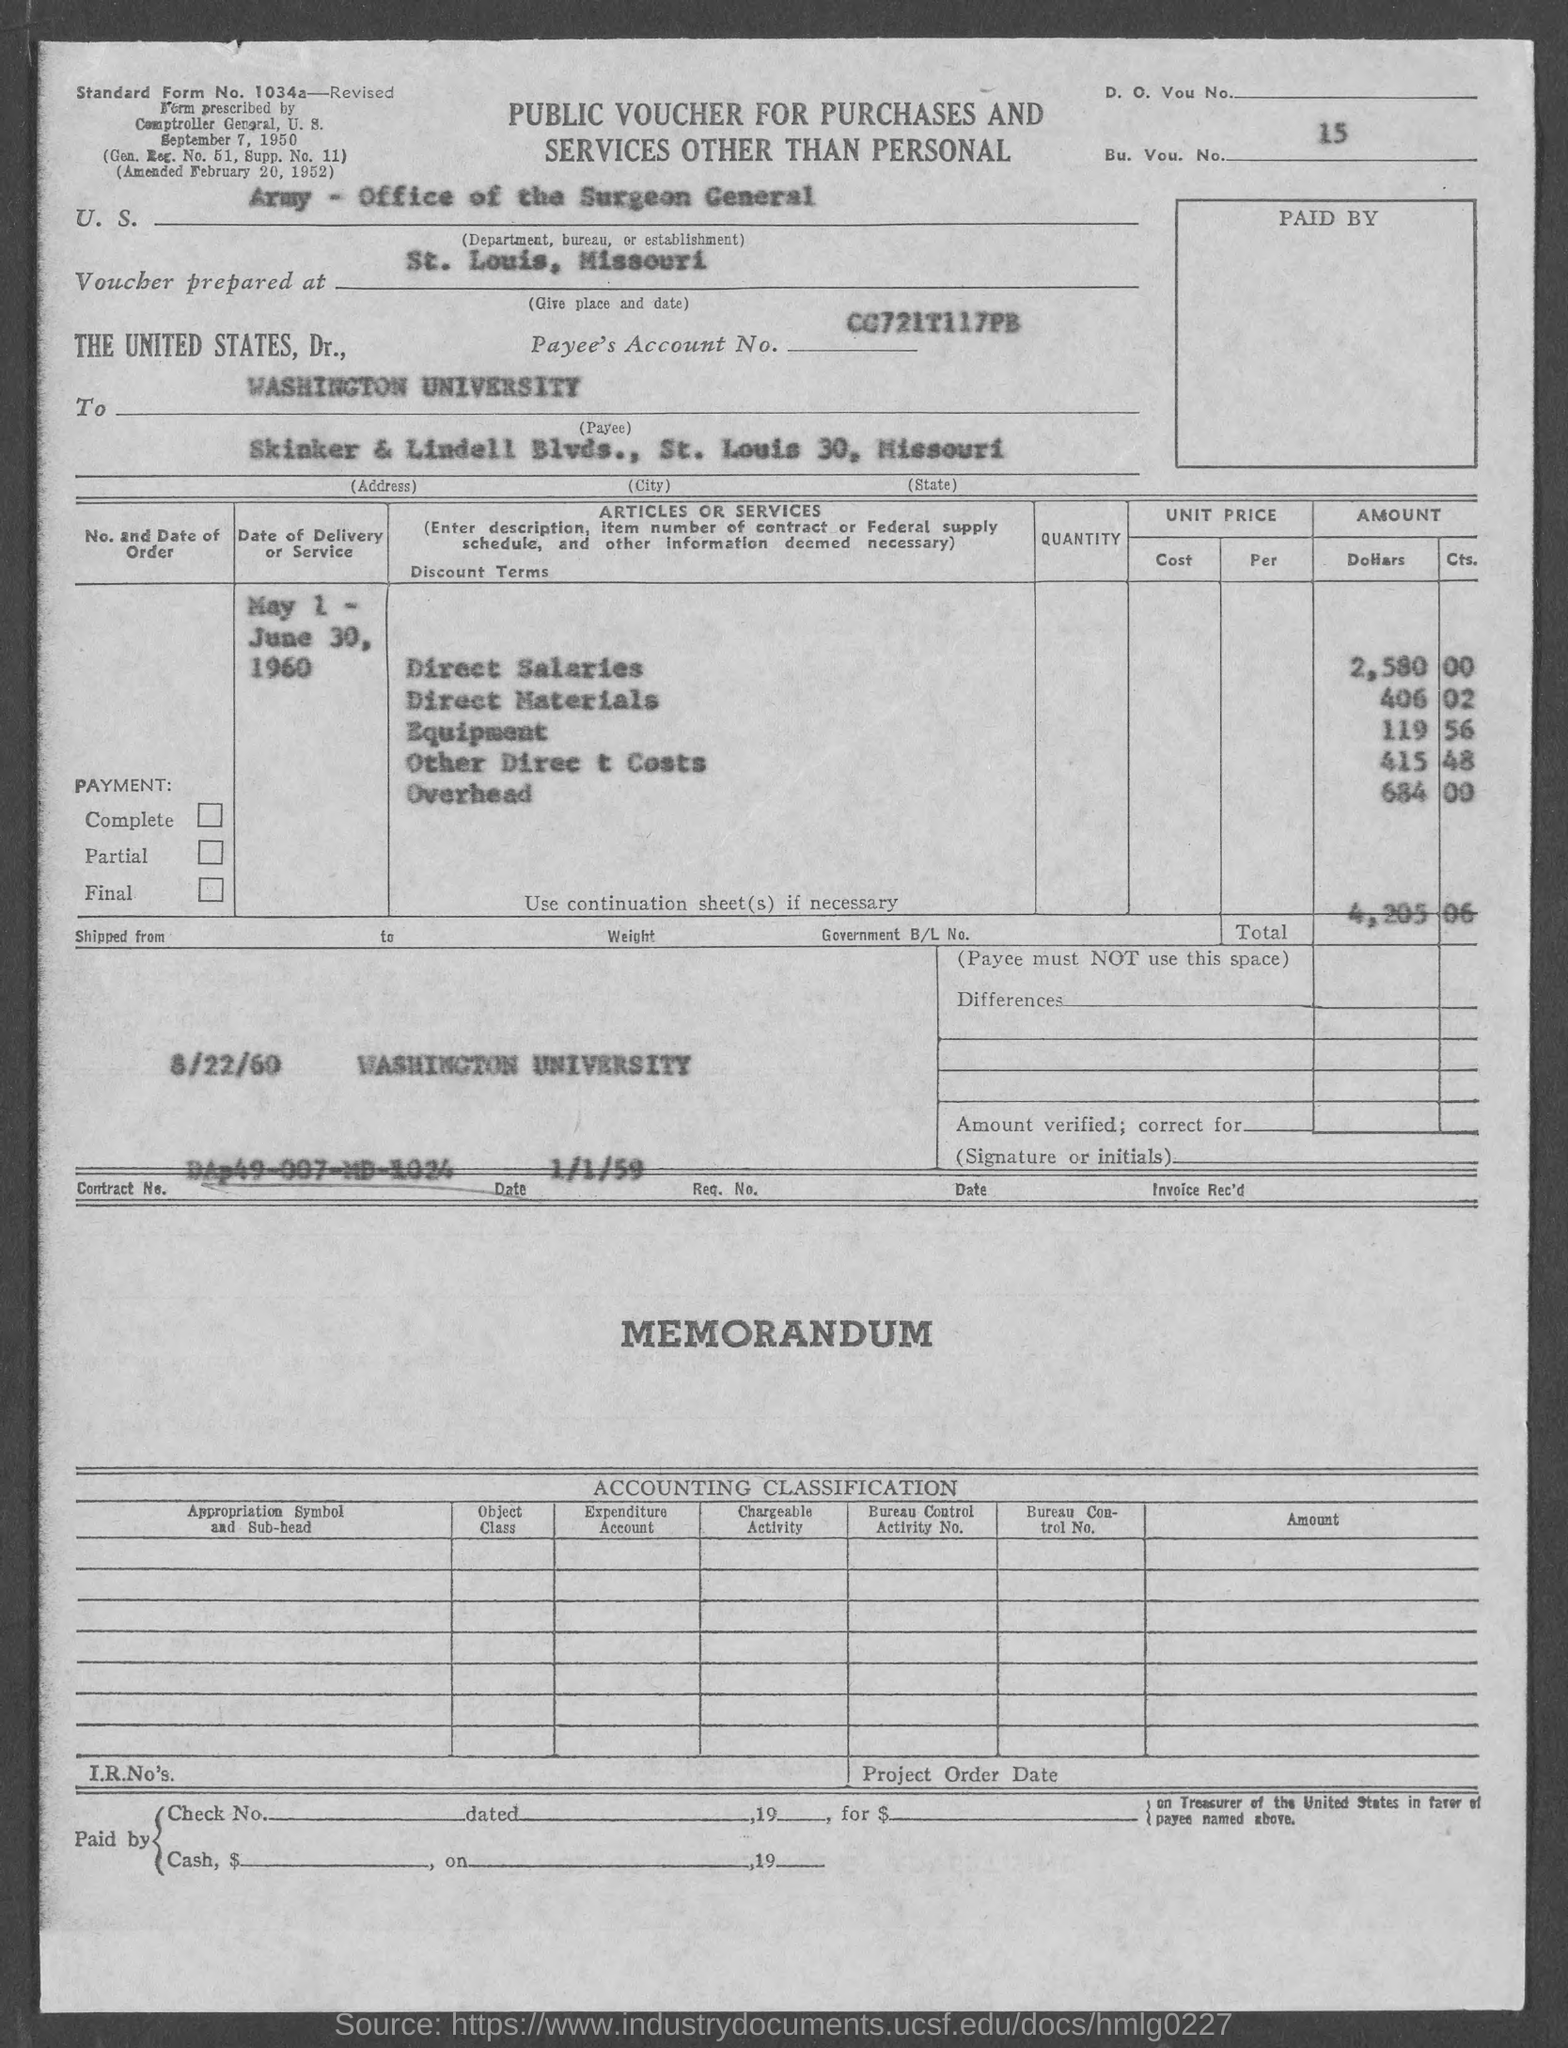What is the bu. vou. no.?
Offer a terse response. 15. What is the standard form no.?
Offer a very short reply. 1034a. In which state is washington university at?
Keep it short and to the point. Missouri. What is the amount of direct salaries ?
Keep it short and to the point. 2,580 00. What is the amount of direct materials ?
Your answer should be compact. 406.02. What is the amount of equipment ?
Make the answer very short. 119.56. What is the amount of other direct costs?
Make the answer very short. 415 48. What is the amount of overhead ?
Give a very brief answer. 684 00. What is the total ?
Your answer should be compact. 4,205.06. What is the gen. reg. no.?
Offer a terse response. 51. 